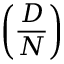Convert formula to latex. <formula><loc_0><loc_0><loc_500><loc_500>\left ( { \frac { D } { N } } \right )</formula> 